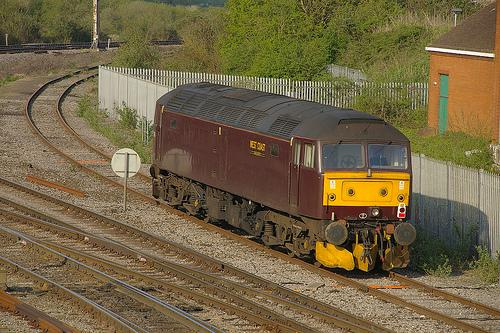Question: how many trains are there?
Choices:
A. 2.
B. 3.
C. 4.
D. 1.
Answer with the letter. Answer: D Question: what is the color of the train?
Choices:
A. Red and yellow.
B. Brown and red.
C. Blue and silver.
D. Red and white.
Answer with the letter. Answer: A Question: what is surrounding the building?
Choices:
A. Trees.
B. Fence.
C. A moat.
D. Rocks.
Answer with the letter. Answer: B 